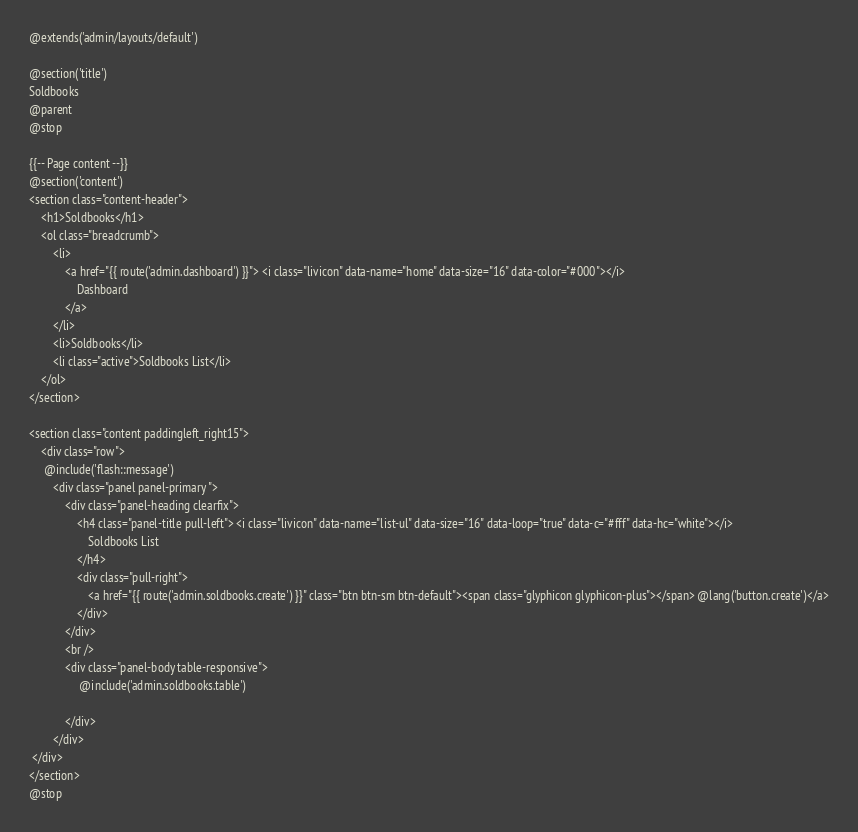Convert code to text. <code><loc_0><loc_0><loc_500><loc_500><_PHP_>@extends('admin/layouts/default')

@section('title')
Soldbooks
@parent
@stop

{{-- Page content --}}
@section('content')
<section class="content-header">
    <h1>Soldbooks</h1>
    <ol class="breadcrumb">
        <li>
            <a href="{{ route('admin.dashboard') }}"> <i class="livicon" data-name="home" data-size="16" data-color="#000"></i>
                Dashboard
            </a>
        </li>
        <li>Soldbooks</li>
        <li class="active">Soldbooks List</li>
    </ol>
</section>

<section class="content paddingleft_right15">
    <div class="row">
     @include('flash::message')
        <div class="panel panel-primary ">
            <div class="panel-heading clearfix">
                <h4 class="panel-title pull-left"> <i class="livicon" data-name="list-ul" data-size="16" data-loop="true" data-c="#fff" data-hc="white"></i>
                    Soldbooks List
                </h4>
                <div class="pull-right">
                    <a href="{{ route('admin.soldbooks.create') }}" class="btn btn-sm btn-default"><span class="glyphicon glyphicon-plus"></span> @lang('button.create')</a>
                </div>
            </div>
            <br />
            <div class="panel-body table-responsive">
                 @include('admin.soldbooks.table')
                 
            </div>
        </div>
 </div>
</section>
@stop
</code> 